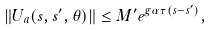Convert formula to latex. <formula><loc_0><loc_0><loc_500><loc_500>\| U _ { a } ( s , s ^ { \prime } , \theta ) \| \leq M ^ { \prime } e ^ { g \alpha \tau ( s - s ^ { \prime } ) } ,</formula> 